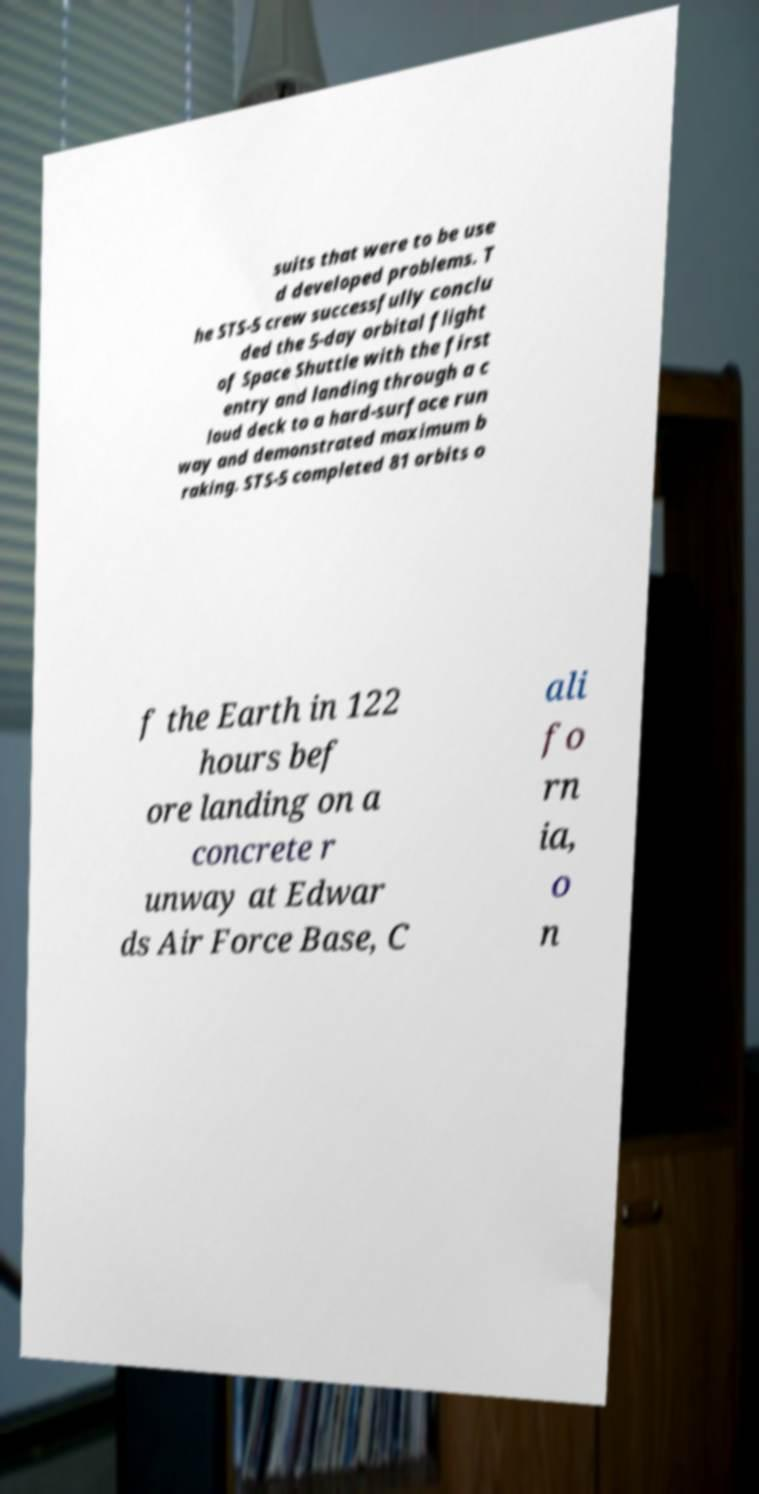Can you read and provide the text displayed in the image?This photo seems to have some interesting text. Can you extract and type it out for me? suits that were to be use d developed problems. T he STS-5 crew successfully conclu ded the 5-day orbital flight of Space Shuttle with the first entry and landing through a c loud deck to a hard-surface run way and demonstrated maximum b raking. STS-5 completed 81 orbits o f the Earth in 122 hours bef ore landing on a concrete r unway at Edwar ds Air Force Base, C ali fo rn ia, o n 